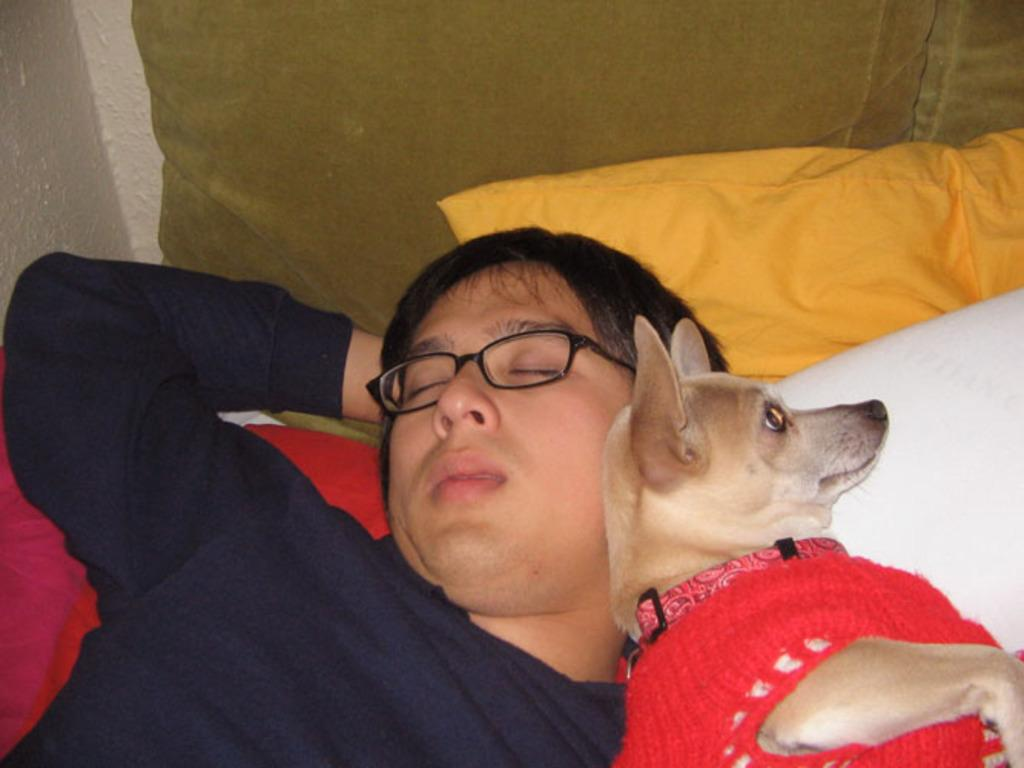Who is present in the image? There is a man and a dog in the image. What are they doing in the image? Both the man and the dog are on a bed. What can be seen on the bed besides the man and the dog? There is a pillow visible in the image. What arithmetic problem is the man solving with the goldfish in the image? There is no goldfish present in the image, and the man is not solving any arithmetic problems. 